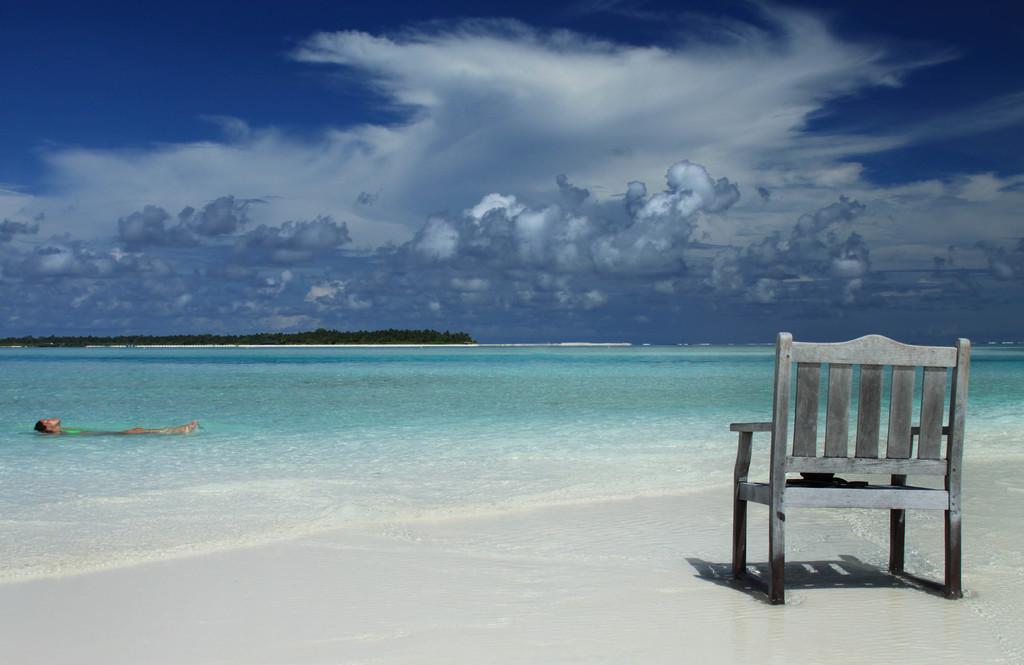Describe this image in one or two sentences. On the right side of the image, we can see a chair on the sea shore. On the left side, we can see a person is swimming in the water. Background there are few trees and cloudy sky. 